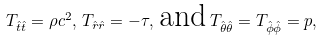Convert formula to latex. <formula><loc_0><loc_0><loc_500><loc_500>T _ { \hat { t } \hat { t } } = \rho c ^ { 2 } , \, T _ { \hat { r } \hat { r } } = - \tau , \, \text {and} \, T _ { \hat { \theta } \hat { \theta } } = T _ { \hat { \phi } \hat { \phi } } = p ,</formula> 